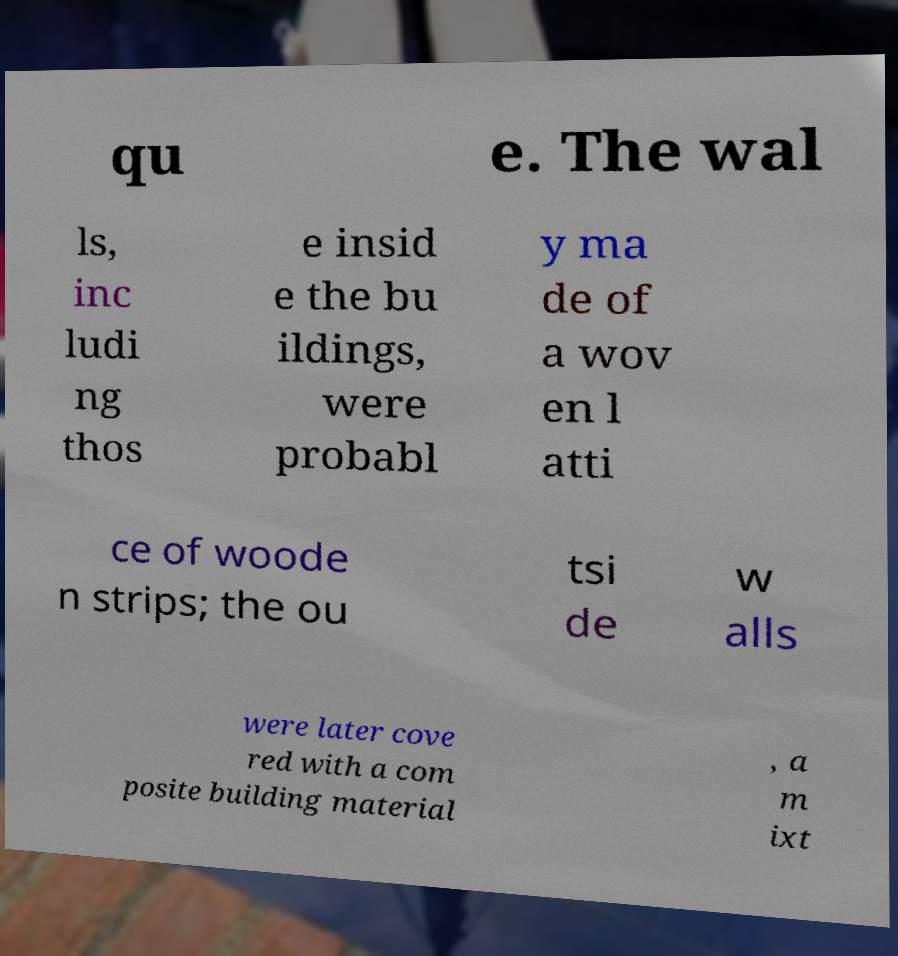Please read and relay the text visible in this image. What does it say? qu e. The wal ls, inc ludi ng thos e insid e the bu ildings, were probabl y ma de of a wov en l atti ce of woode n strips; the ou tsi de w alls were later cove red with a com posite building material , a m ixt 